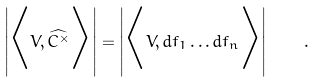<formula> <loc_0><loc_0><loc_500><loc_500>\left | \Big { < } V , \widehat { C ^ { \times } } \Big { > } \right | = \left | \Big { < } V , d f _ { 1 } \dots d f _ { n } \Big { > } \right | \quad .</formula> 